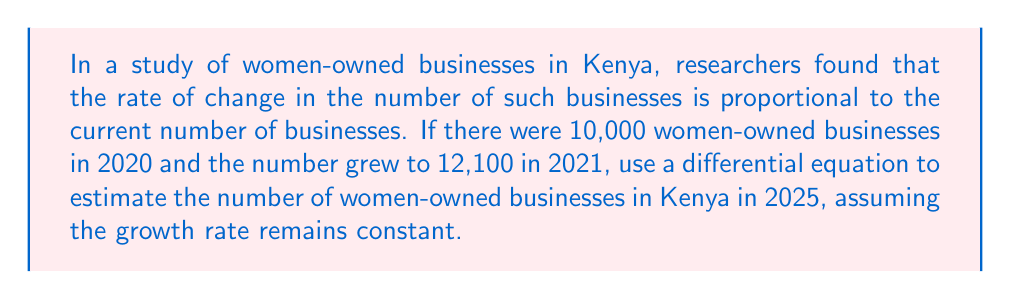Could you help me with this problem? Let's approach this step-by-step using a differential equation:

1) Let $N(t)$ be the number of women-owned businesses at time $t$, where $t$ is measured in years since 2020.

2) The given information suggests that the rate of change is proportional to the current number:

   $$\frac{dN}{dt} = kN$$

   where $k$ is the growth rate constant.

3) This differential equation has the solution:

   $$N(t) = N_0e^{kt}$$

   where $N_0$ is the initial number of businesses.

4) We know that:
   $N_0 = 10,000$ (in 2020)
   $N(1) = 12,100$ (in 2021)

5) Let's find $k$:

   $$12,100 = 10,000e^k$$
   $$e^k = 1.21$$
   $$k = \ln(1.21) \approx 0.1906$$

6) Now we have our complete model:

   $$N(t) = 10,000e^{0.1906t}$$

7) To find the number in 2025, we calculate $N(5)$:

   $$N(5) = 10,000e^{0.1906 * 5} \approx 25,790$$

Therefore, we estimate there will be approximately 25,790 women-owned businesses in Kenya in 2025.
Answer: Approximately 25,790 women-owned businesses in Kenya in 2025. 